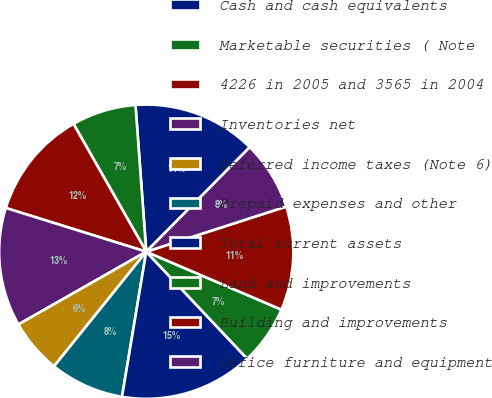<chart> <loc_0><loc_0><loc_500><loc_500><pie_chart><fcel>Cash and cash equivalents<fcel>Marketable securities ( Note<fcel>4226 in 2005 and 3565 in 2004<fcel>Inventories net<fcel>Deferred income taxes (Note 6)<fcel>Prepaid expenses and other<fcel>Total current assets<fcel>Land and improvements<fcel>Building and improvements<fcel>Office furniture and equipment<nl><fcel>13.59%<fcel>7.07%<fcel>11.96%<fcel>13.04%<fcel>5.98%<fcel>8.15%<fcel>14.67%<fcel>6.52%<fcel>11.41%<fcel>7.61%<nl></chart> 